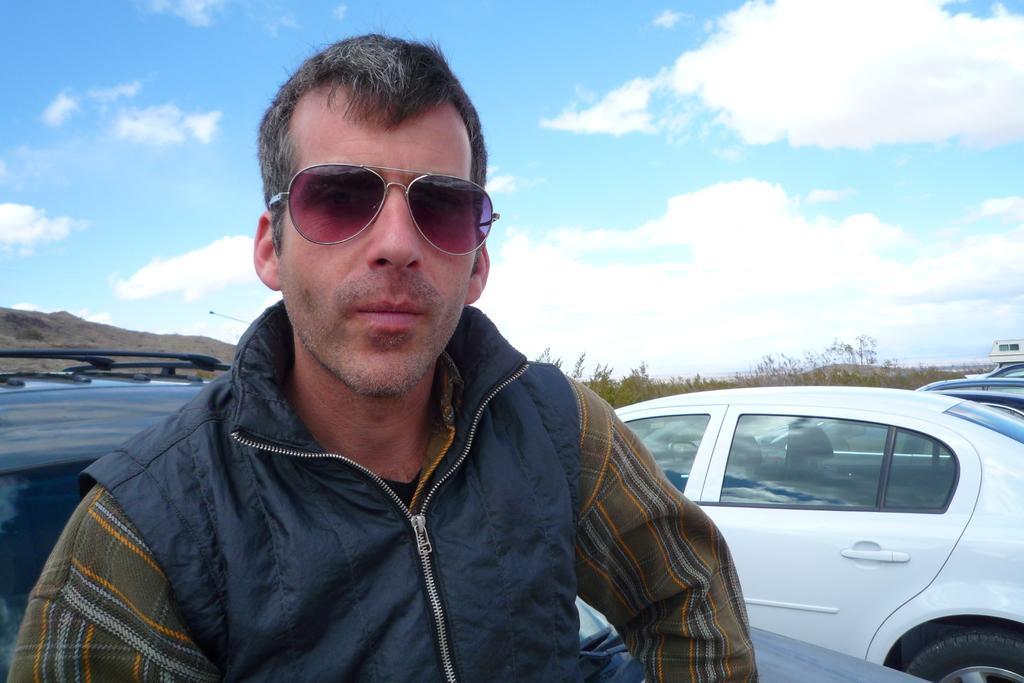In one or two sentences, can you explain what this image depicts? In this picture we can see a man with goggles. Behind the man there are some vehicles on the path, trees, hills and a sky. 